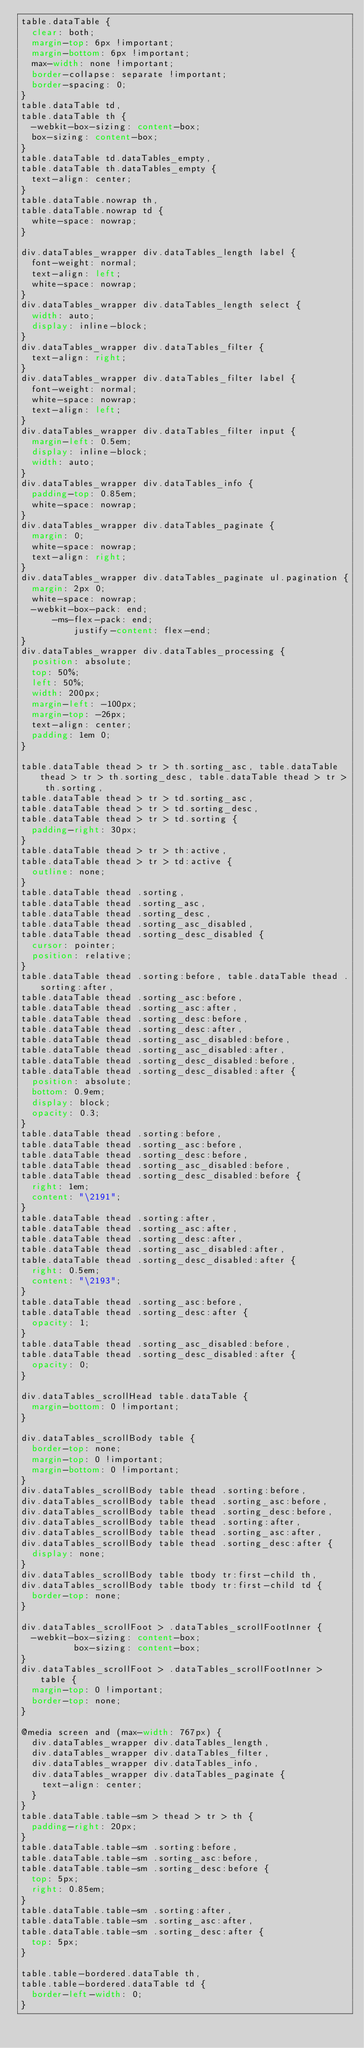<code> <loc_0><loc_0><loc_500><loc_500><_CSS_>table.dataTable {
  clear: both;
  margin-top: 6px !important;
  margin-bottom: 6px !important;
  max-width: none !important;
  border-collapse: separate !important;
  border-spacing: 0;
}
table.dataTable td,
table.dataTable th {
  -webkit-box-sizing: content-box;
  box-sizing: content-box;
}
table.dataTable td.dataTables_empty,
table.dataTable th.dataTables_empty {
  text-align: center;
}
table.dataTable.nowrap th,
table.dataTable.nowrap td {
  white-space: nowrap;
}

div.dataTables_wrapper div.dataTables_length label {
  font-weight: normal;
  text-align: left;
  white-space: nowrap;
}
div.dataTables_wrapper div.dataTables_length select {
  width: auto;
  display: inline-block;
}
div.dataTables_wrapper div.dataTables_filter {
  text-align: right;
}
div.dataTables_wrapper div.dataTables_filter label {
  font-weight: normal;
  white-space: nowrap;
  text-align: left;
}
div.dataTables_wrapper div.dataTables_filter input {
  margin-left: 0.5em;
  display: inline-block;
  width: auto;
}
div.dataTables_wrapper div.dataTables_info {
  padding-top: 0.85em;
  white-space: nowrap;
}
div.dataTables_wrapper div.dataTables_paginate {
  margin: 0;
  white-space: nowrap;
  text-align: right;
}
div.dataTables_wrapper div.dataTables_paginate ul.pagination {
  margin: 2px 0;
  white-space: nowrap;
  -webkit-box-pack: end;
      -ms-flex-pack: end;
          justify-content: flex-end;
}
div.dataTables_wrapper div.dataTables_processing {
  position: absolute;
  top: 50%;
  left: 50%;
  width: 200px;
  margin-left: -100px;
  margin-top: -26px;
  text-align: center;
  padding: 1em 0;
}

table.dataTable thead > tr > th.sorting_asc, table.dataTable thead > tr > th.sorting_desc, table.dataTable thead > tr > th.sorting,
table.dataTable thead > tr > td.sorting_asc,
table.dataTable thead > tr > td.sorting_desc,
table.dataTable thead > tr > td.sorting {
  padding-right: 30px;
}
table.dataTable thead > tr > th:active,
table.dataTable thead > tr > td:active {
  outline: none;
}
table.dataTable thead .sorting,
table.dataTable thead .sorting_asc,
table.dataTable thead .sorting_desc,
table.dataTable thead .sorting_asc_disabled,
table.dataTable thead .sorting_desc_disabled {
  cursor: pointer;
  position: relative;
}
table.dataTable thead .sorting:before, table.dataTable thead .sorting:after,
table.dataTable thead .sorting_asc:before,
table.dataTable thead .sorting_asc:after,
table.dataTable thead .sorting_desc:before,
table.dataTable thead .sorting_desc:after,
table.dataTable thead .sorting_asc_disabled:before,
table.dataTable thead .sorting_asc_disabled:after,
table.dataTable thead .sorting_desc_disabled:before,
table.dataTable thead .sorting_desc_disabled:after {
  position: absolute;
  bottom: 0.9em;
  display: block;
  opacity: 0.3;
}
table.dataTable thead .sorting:before,
table.dataTable thead .sorting_asc:before,
table.dataTable thead .sorting_desc:before,
table.dataTable thead .sorting_asc_disabled:before,
table.dataTable thead .sorting_desc_disabled:before {
  right: 1em;
  content: "\2191";
}
table.dataTable thead .sorting:after,
table.dataTable thead .sorting_asc:after,
table.dataTable thead .sorting_desc:after,
table.dataTable thead .sorting_asc_disabled:after,
table.dataTable thead .sorting_desc_disabled:after {
  right: 0.5em;
  content: "\2193";
}
table.dataTable thead .sorting_asc:before,
table.dataTable thead .sorting_desc:after {
  opacity: 1;
}
table.dataTable thead .sorting_asc_disabled:before,
table.dataTable thead .sorting_desc_disabled:after {
  opacity: 0;
}

div.dataTables_scrollHead table.dataTable {
  margin-bottom: 0 !important;
}

div.dataTables_scrollBody table {
  border-top: none;
  margin-top: 0 !important;
  margin-bottom: 0 !important;
}
div.dataTables_scrollBody table thead .sorting:before,
div.dataTables_scrollBody table thead .sorting_asc:before,
div.dataTables_scrollBody table thead .sorting_desc:before,
div.dataTables_scrollBody table thead .sorting:after,
div.dataTables_scrollBody table thead .sorting_asc:after,
div.dataTables_scrollBody table thead .sorting_desc:after {
  display: none;
}
div.dataTables_scrollBody table tbody tr:first-child th,
div.dataTables_scrollBody table tbody tr:first-child td {
  border-top: none;
}

div.dataTables_scrollFoot > .dataTables_scrollFootInner {
  -webkit-box-sizing: content-box;
          box-sizing: content-box;
}
div.dataTables_scrollFoot > .dataTables_scrollFootInner > table {
  margin-top: 0 !important;
  border-top: none;
}

@media screen and (max-width: 767px) {
  div.dataTables_wrapper div.dataTables_length,
  div.dataTables_wrapper div.dataTables_filter,
  div.dataTables_wrapper div.dataTables_info,
  div.dataTables_wrapper div.dataTables_paginate {
    text-align: center;
  }
}
table.dataTable.table-sm > thead > tr > th {
  padding-right: 20px;
}
table.dataTable.table-sm .sorting:before,
table.dataTable.table-sm .sorting_asc:before,
table.dataTable.table-sm .sorting_desc:before {
  top: 5px;
  right: 0.85em;
}
table.dataTable.table-sm .sorting:after,
table.dataTable.table-sm .sorting_asc:after,
table.dataTable.table-sm .sorting_desc:after {
  top: 5px;
}

table.table-bordered.dataTable th,
table.table-bordered.dataTable td {
  border-left-width: 0;
}</code> 